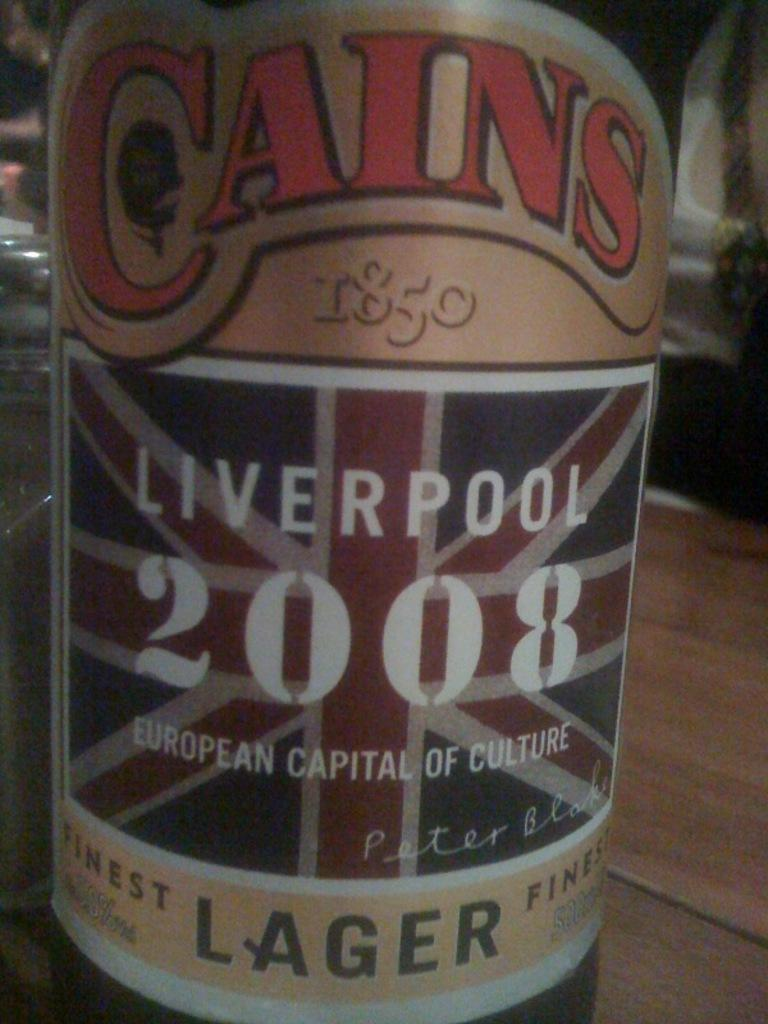<image>
Present a compact description of the photo's key features. A bottle of Cains Liverpool 2008 Lager sits on a wood table. 